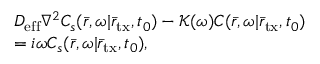Convert formula to latex. <formula><loc_0><loc_0><loc_500><loc_500>\begin{array} { r l } & { D _ { e f f } { \nabla ^ { 2 } } C _ { s } ( \bar { r } , \omega | { { \bar { r } } _ { t x } } , { t _ { 0 } } ) - \mathcal { K } ( \omega ) C ( \bar { r } , \omega | { { \bar { r } } _ { t x } } , { t _ { 0 } } ) } \\ & { = i \omega C _ { s } ( \bar { r } , \omega | { { \bar { r } } _ { t x } } , { t _ { 0 } } ) , } \end{array}</formula> 